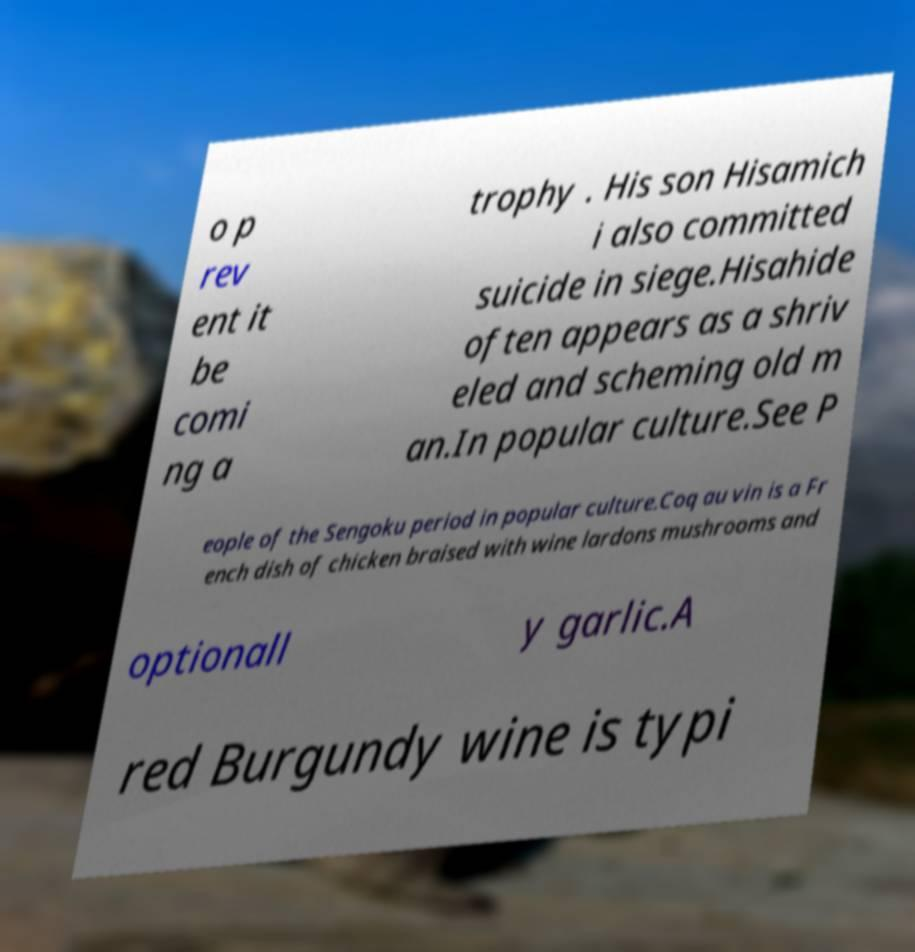What messages or text are displayed in this image? I need them in a readable, typed format. o p rev ent it be comi ng a trophy . His son Hisamich i also committed suicide in siege.Hisahide often appears as a shriv eled and scheming old m an.In popular culture.See P eople of the Sengoku period in popular culture.Coq au vin is a Fr ench dish of chicken braised with wine lardons mushrooms and optionall y garlic.A red Burgundy wine is typi 